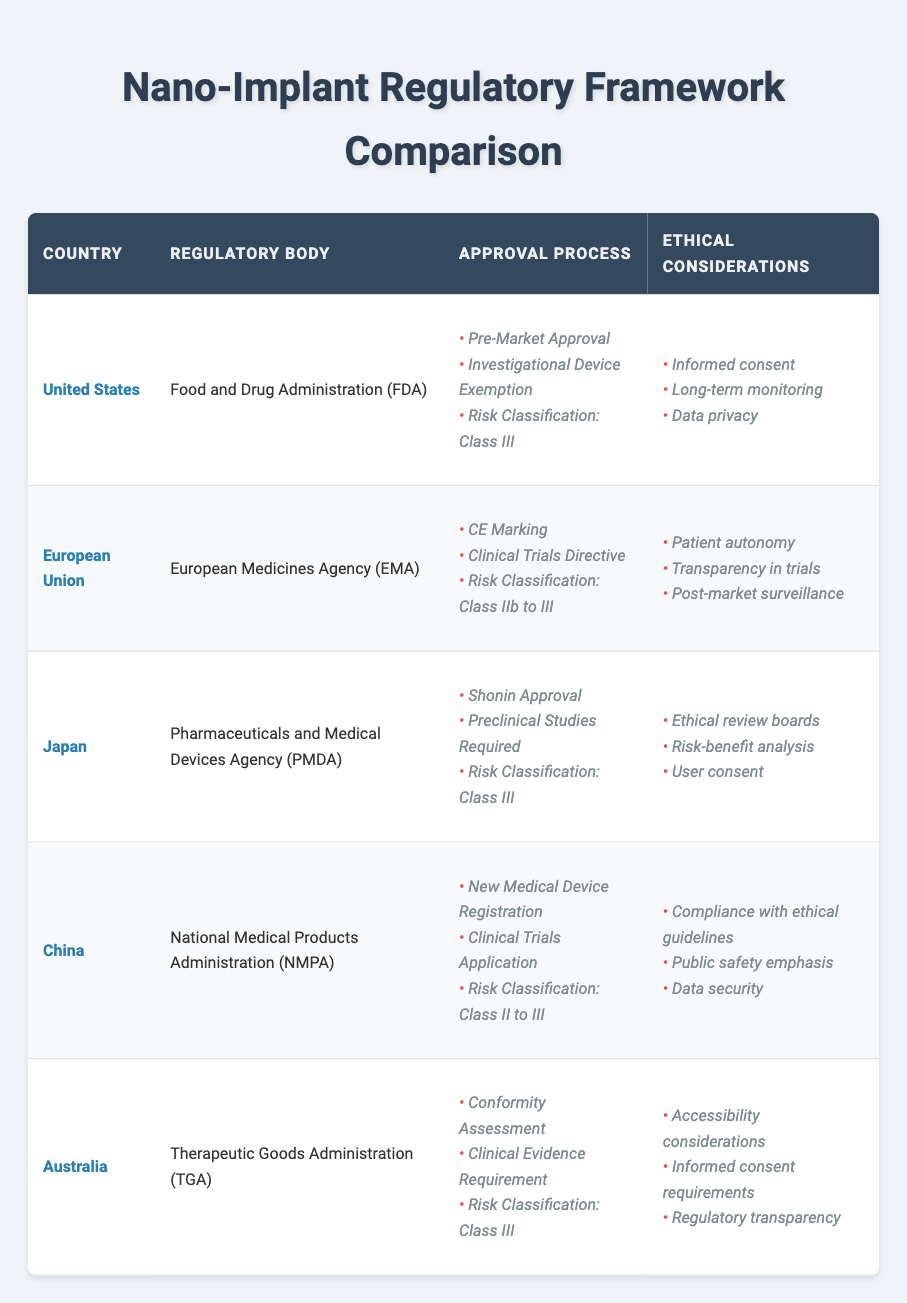What regulatory body oversees nano-implants in the United States? The table indicates that the regulatory body in the United States is the Food and Drug Administration (FDA), based on the corresponding row for the country.
Answer: Food and Drug Administration (FDA) Which countries classify nano-implants as Class III devices? By examining the approval process column, we see that the United States, Japan, and Australia classify nano-implants as Class III devices, represented in their respective rows.
Answer: United States, Japan, Australia Does the European Union require informed consent for nano-implants? The table shows that the ethical considerations for the European Union include patient autonomy and transparency in trials, but there is no mention of informed consent specifically. Thus the answer is no.
Answer: No What is the most common risk classification for nano-implants among the countries listed? By checking each country's risk classification, we find that both Class III and Class II to III classifications appear. However, Class III is explicitly stated for four countries (United States, Japan, Australia) compared to two countries (European Union, China) with Class II to III, making Class III more common.
Answer: Class III Which country emphasizes public safety in its ethical considerations for nano-implants? In the table, China is the only country that includes an emphasis on public safety among its ethical considerations, as shown in the corresponding row under ethical considerations.
Answer: China How many countries require clinical trials as part of their approval processes? Analyzing the approval process column reveals that four countries (European Union, Japan, China, and Australia) require clinical trials in some form, reflecting that they have clinical trial-related processes, while the United States does not require clinical trials as per the row content.
Answer: Four What ethical consideration is unique to Japan among the countries listed? The unique ethical consideration listed for Japan is the presence of ethical review boards, as indicated by the content in the ethical considerations column for that country, which is not mentioned for any others.
Answer: Ethical review boards What are two ethical considerations that both the United States and Australia share? Both countries include informed consent and regulatory transparency within their ethical considerations, which can be confirmed by reviewing the relevant rows in the table for each.
Answer: Informed consent, regulatory transparency Which country has the least restrictive risk classification for nano-implants? By examining the risk classifications across the countries, the European Union and China show classifications of Class II to III, indicating less strict regulation compared to Class III alone. Hence, they represent less restrictive classifications.
Answer: European Union, China 